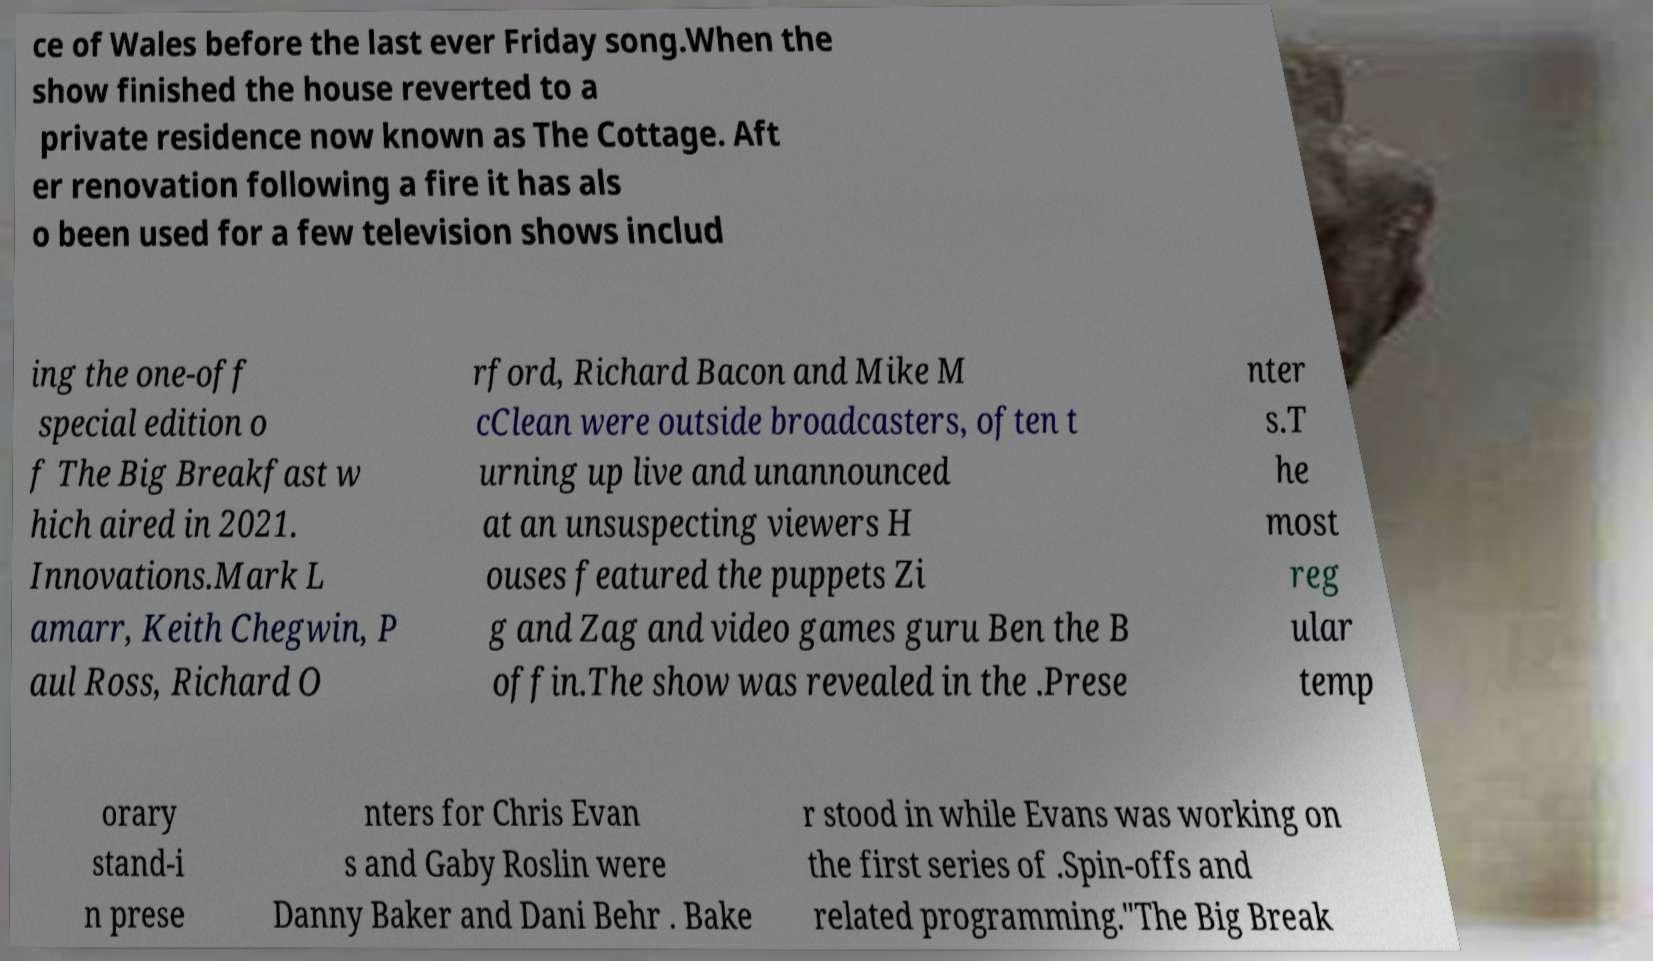Can you accurately transcribe the text from the provided image for me? ce of Wales before the last ever Friday song.When the show finished the house reverted to a private residence now known as The Cottage. Aft er renovation following a fire it has als o been used for a few television shows includ ing the one-off special edition o f The Big Breakfast w hich aired in 2021. Innovations.Mark L amarr, Keith Chegwin, P aul Ross, Richard O rford, Richard Bacon and Mike M cClean were outside broadcasters, often t urning up live and unannounced at an unsuspecting viewers H ouses featured the puppets Zi g and Zag and video games guru Ben the B offin.The show was revealed in the .Prese nter s.T he most reg ular temp orary stand-i n prese nters for Chris Evan s and Gaby Roslin were Danny Baker and Dani Behr . Bake r stood in while Evans was working on the first series of .Spin-offs and related programming."The Big Break 